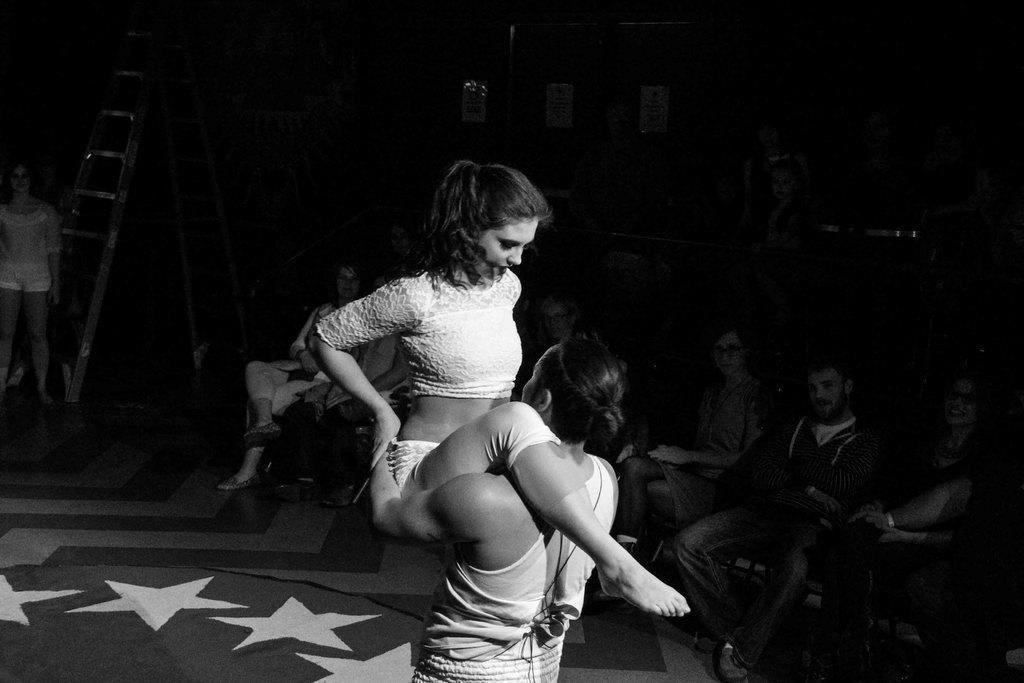Could you give a brief overview of what you see in this image? This is a black and white image of a man and woman dancing on stage and in the back there are many people sitting on chairs and staring at them. 